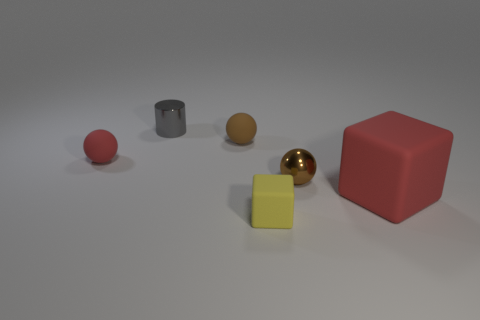The yellow matte block has what size?
Make the answer very short. Small. Is the number of big things that are on the right side of the large red matte thing greater than the number of yellow rubber things that are to the left of the tiny gray cylinder?
Keep it short and to the point. No. Are there any brown matte objects behind the small gray object?
Provide a succinct answer. No. Are there any red rubber cylinders that have the same size as the yellow matte block?
Provide a succinct answer. No. There is a large thing that is made of the same material as the small red sphere; what color is it?
Ensure brevity in your answer.  Red. What is the material of the red block?
Offer a very short reply. Rubber. What is the shape of the brown rubber thing?
Give a very brief answer. Sphere. What number of small objects have the same color as the metal ball?
Keep it short and to the point. 1. There is a tiny brown ball that is right of the brown ball behind the small brown object that is in front of the small red rubber object; what is its material?
Keep it short and to the point. Metal. What number of blue objects are either small blocks or rubber balls?
Make the answer very short. 0. 